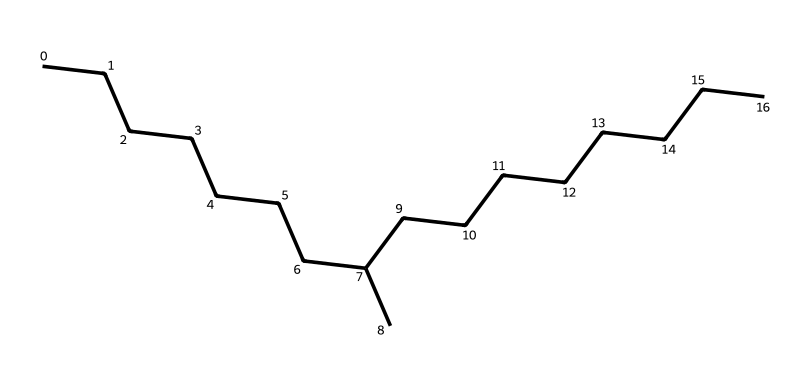How many carbon atoms are in the structure? The structural formula shows a long chain of carbon atoms that can be counted from the SMILES notation where 'C' represents carbon. By analyzing the sequence, there are 30 carbon atoms in total.
Answer: 30 What type of chemical structure is represented here? The SMILES notation indicates a straight-chain hydrocarbon, specifically an alkane due to the absence of double or triple bonds. The formula reflects a fully saturated carbon chain.
Answer: alkane What is the longest continuous carbon chain in this structure? From the SMILES representation, we observe a long continuous chain of carbon atoms. The longest chain corresponds to those connected without any branching, which comprises 30 carbons.
Answer: 30 Are there any functional groups present in this chemical? The SMILES notation lacks indicators for functional groups, such as hydroxyl (–OH) or carboxyl (–COOH), implying that this is a simple hydrocarbon without additional functional groups that characterize other chemical classes.
Answer: no What is the molecular formula based on the structure shown? To derive the molecular formula from the SMILES, we combine the carbon and hydrogen counts. The chain has 30 carbon atoms and, following alkane rules, would yield 62 hydrogen atoms, leading to the molecular formula C30H62.
Answer: C30H62 Does this chemical have any potential uses in ice resurfacing? Given its saturated hydrocarbon nature and properties of lubricity, this chemical can function effectively as a lubricant in ice resurfacing machines, reducing friction and wear during operation.
Answer: yes 